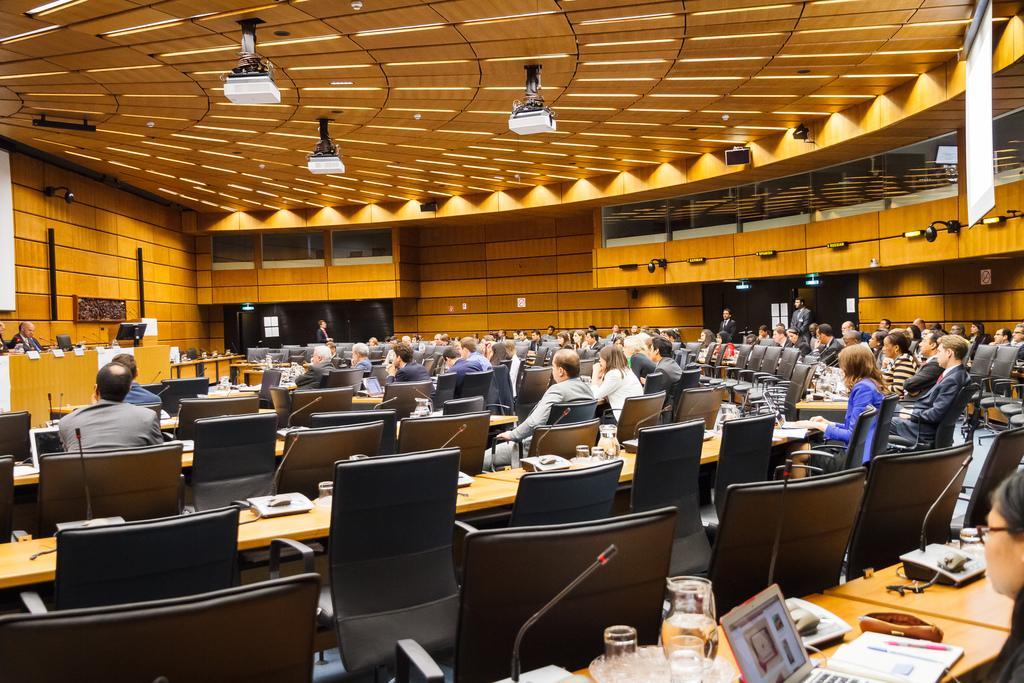Please provide a concise description of this image. In this picture a group of people sitting on a chair. This picture is taken in a conference room. In the background two men are standing. At the left side one man is standing. In the front there is a laptop on the table glasses, jar, mic. On the top there are projectors hanging on the top. 